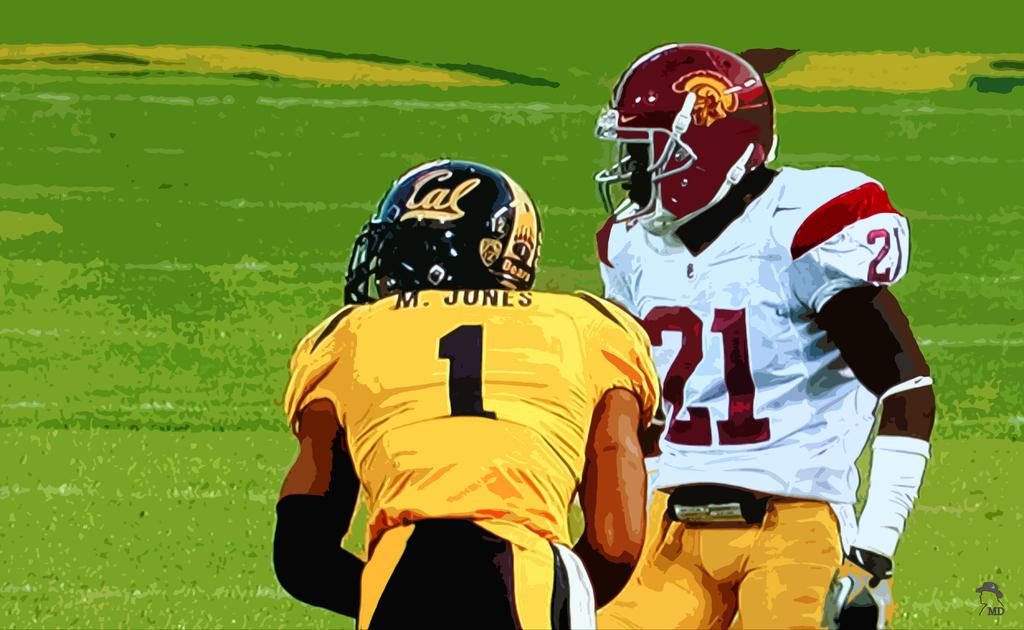How many rugby players are in the image? There are two rugby players in the image. What are the rugby players doing in the image? The rugby players are standing on the ground. What protective gear are the rugby players wearing? The rugby players are wearing helmets and gloves. What type of business is being conducted by the rugby players in the image? There is no indication of any business being conducted in the image; the rugby players are simply standing on the ground wearing helmets and gloves. 